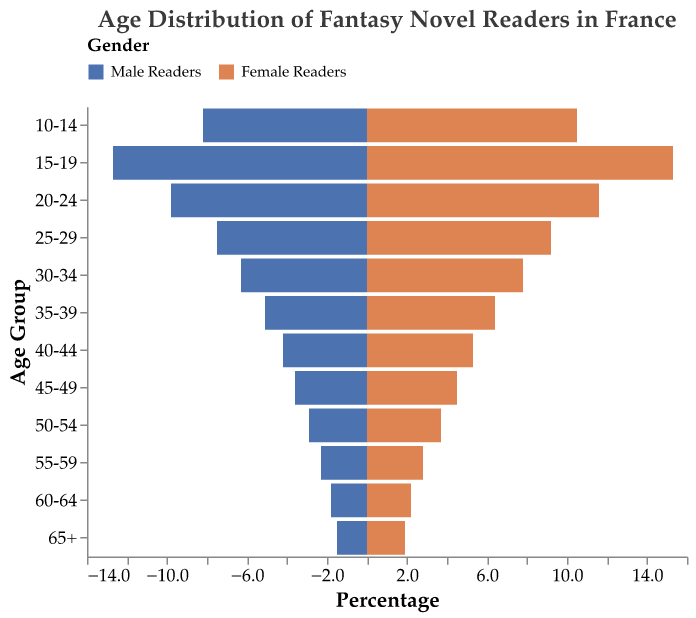What does the title of the figure indicate? The title of the figure is "Age Distribution of Fantasy Novel Readers in France," which indicates that the plot represents the age distribution of fantasy novel readers in France, divided by gender.
Answer: Age Distribution of Fantasy Novel Readers in France What are the colors used to represent male and female readers? The colors used in the figure are blue for male readers and orange for female readers.
Answer: Blue for male readers, orange for female readers Which age group has the highest percentage of male readers? To determine this, look for the age group with the longest bar in blue on the male readers' side. The age group "15-19" has the highest percentage of male readers.
Answer: 15-19 Which age group has the lowest percentage of female readers? Look for the age group with the shortest bar in orange on the female readers' side. The age group "65+" has the lowest percentage of female readers.
Answer: 65+ How does the percentage of readers aged 25-29 compare between male and female readers? Check the length of the bars for age group "25-29". The male readers' bar is at 7.5%, while the female readers' bar is at 9.2%. Therefore, the percentage of readers aged 25-29 is higher for female readers than for male readers.
Answer: Higher for female readers What is the sum of the percentages of male readers aged 10-14 and 15-19? Add the percentages of male readers in the age groups 10-14 and 15-19: 8.2% + 12.7% = 20.9%
Answer: 20.9% Is the percentage of female readers aged 20-24 greater than the percentage of male readers aged 20-24? Compare the percentages of female and male readers in the age group 20-24. The female percentage is 11.6%, and the male percentage is 9.8%. Hence, the percentage of female readers is greater.
Answer: Yes Which age groups show a higher percentage of female readers compared to male readers? Compare the percentages for each age group. Female readers have higher percentages in all age groups compared to male readers.
Answer: All age groups How does the percentage of readers aged 35-39 compare between male and female readers? For the age group 35-39, compare the lengths of the bars: male readers (5.1%) and female readers (6.4%). Female readers have a higher percentage than male readers.
Answer: Higher for female readers 